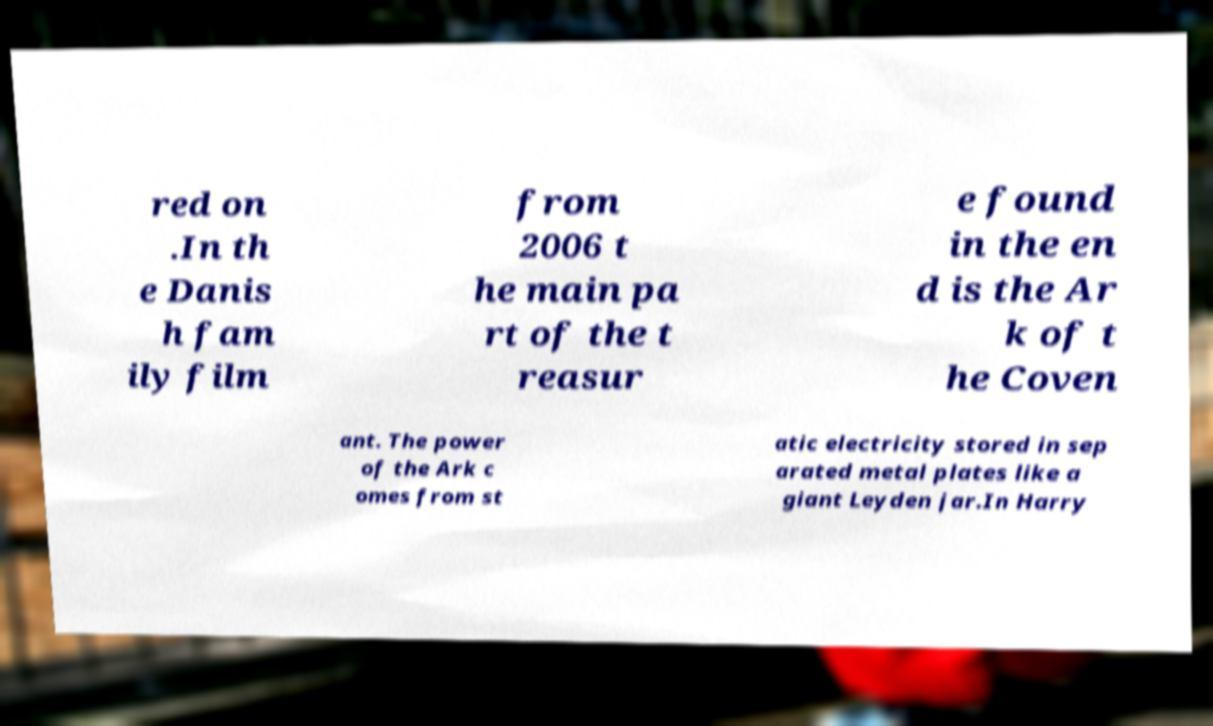For documentation purposes, I need the text within this image transcribed. Could you provide that? red on .In th e Danis h fam ily film from 2006 t he main pa rt of the t reasur e found in the en d is the Ar k of t he Coven ant. The power of the Ark c omes from st atic electricity stored in sep arated metal plates like a giant Leyden jar.In Harry 